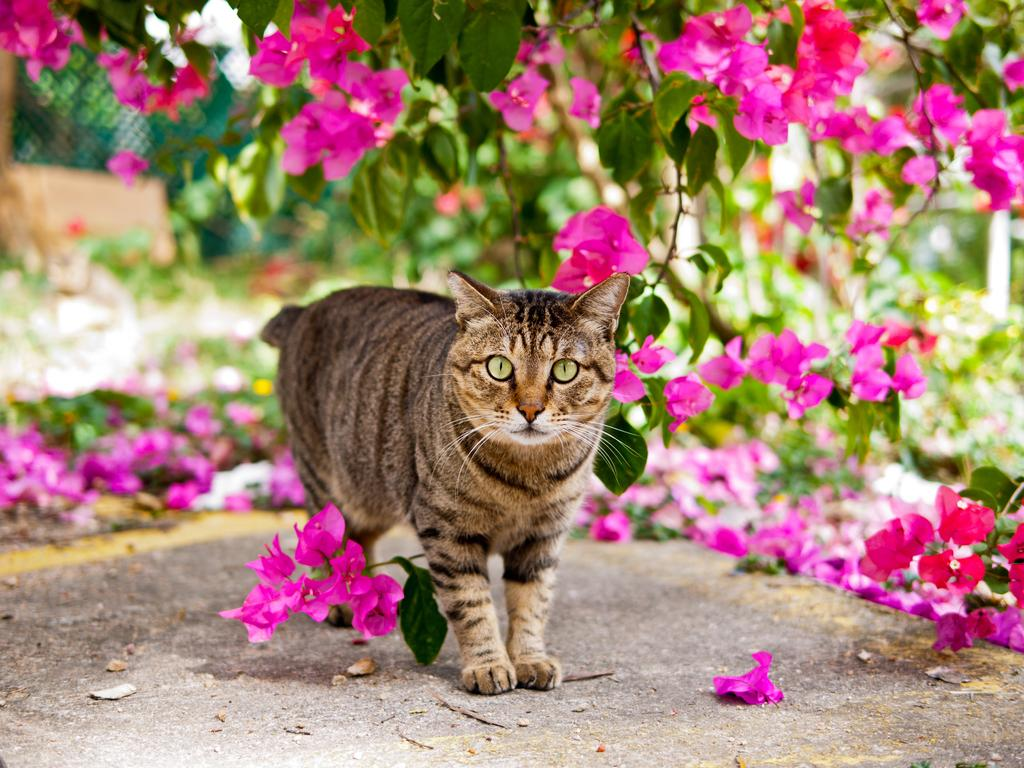What animal can be seen in the image? There is a cat in the image. Where is the cat located? The cat is standing on a path. What can be seen in the background of the image? There are plants with pink flowers in the background. What else is present on the path? Some flowers have fallen on the path. Are there any fairies working together to create the pink flowers in the image? There is no mention of fairies or any work being done by them in the image. The pink flowers are simply part of the background vegetation. 